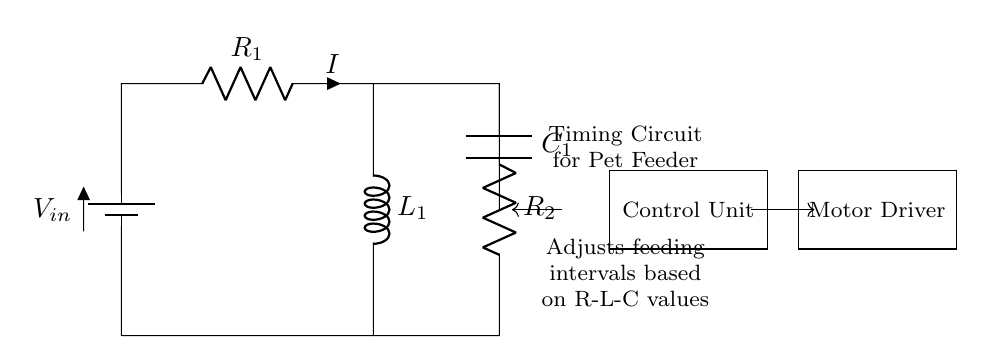What are the components used in this circuit? The circuit consists of a battery, two resistors, one inductor, and a capacitor. Each component is identified and labeled within the diagram.
Answer: battery, resistors, inductor, capacitor What is the function of the inductor in this circuit? The inductor is used to store energy in a magnetic field and contribute to the timing characteristics by creating a delay in the response to changes in current.
Answer: timing What is the role of the control unit in this circuit? The control unit adjusts the feeding intervals based on the timing provided by the R-L-C elements, which determines when the feeder should dispense food.
Answer: adjusts feeding intervals What happens when resistance values increase in this circuit? Increasing resistance values will affect the time constant of the circuit, slowing down the charging/discharging process, which in turn affects the timing intervals for feeding.
Answer: slows timing What is the total resistance in series for this circuit? The total resistance in series is the sum of the two resistors, R1 and R2, which is the effective resistance that limits the current flowing through the circuit.
Answer: R1 + R2 How does the capacitor influence the feeding mechanism? The capacitor influences the feeding mechanism by storing electrical energy and releasing it at a controlled rate, affecting the timing and duration of the feeding action.
Answer: stores energy What type of information is conveyed by the circuit's timing diagram? The timing diagram conveys the intervals and duration for the pet feeder's operations, showing how often and when the feeding mechanism will activate based on the R-L-C values.
Answer: feeding intervals 